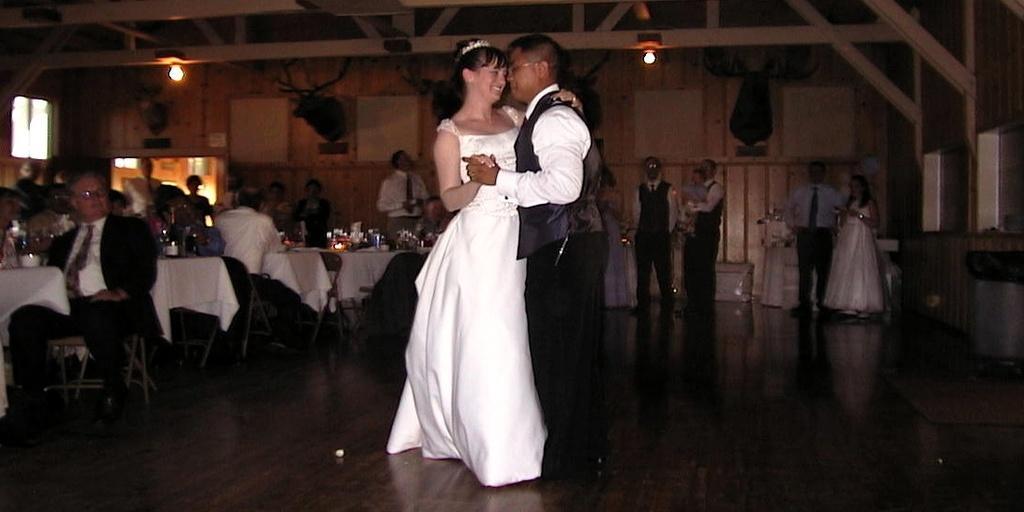How would you summarize this image in a sentence or two? In this image we can see some people standing on the floor. On the left side of the image we can see a group of people sitting on chairs, we can also see bottles, candle and some objects placed on the tables. In the background, we can see windows, some decors on the wall and some lights on the roof. On the right side of the image we can see a trash bin placed on the ground. 